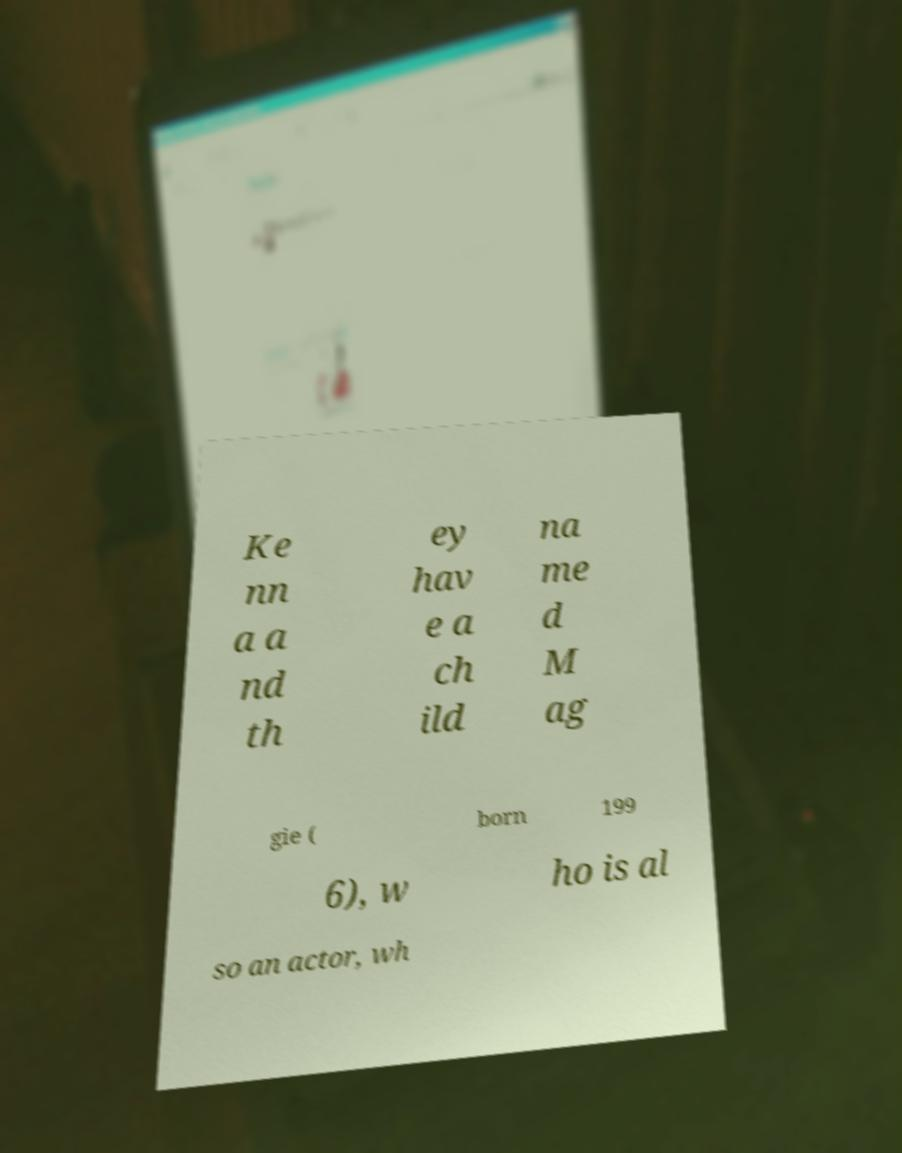Can you accurately transcribe the text from the provided image for me? Ke nn a a nd th ey hav e a ch ild na me d M ag gie ( born 199 6), w ho is al so an actor, wh 